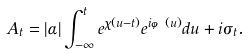Convert formula to latex. <formula><loc_0><loc_0><loc_500><loc_500>A _ { t } = | \alpha | \int _ { - \infty } ^ { t } e ^ { \chi ( u - t ) } e ^ { i \varphi ( u ) } d u + i \sigma _ { t } .</formula> 